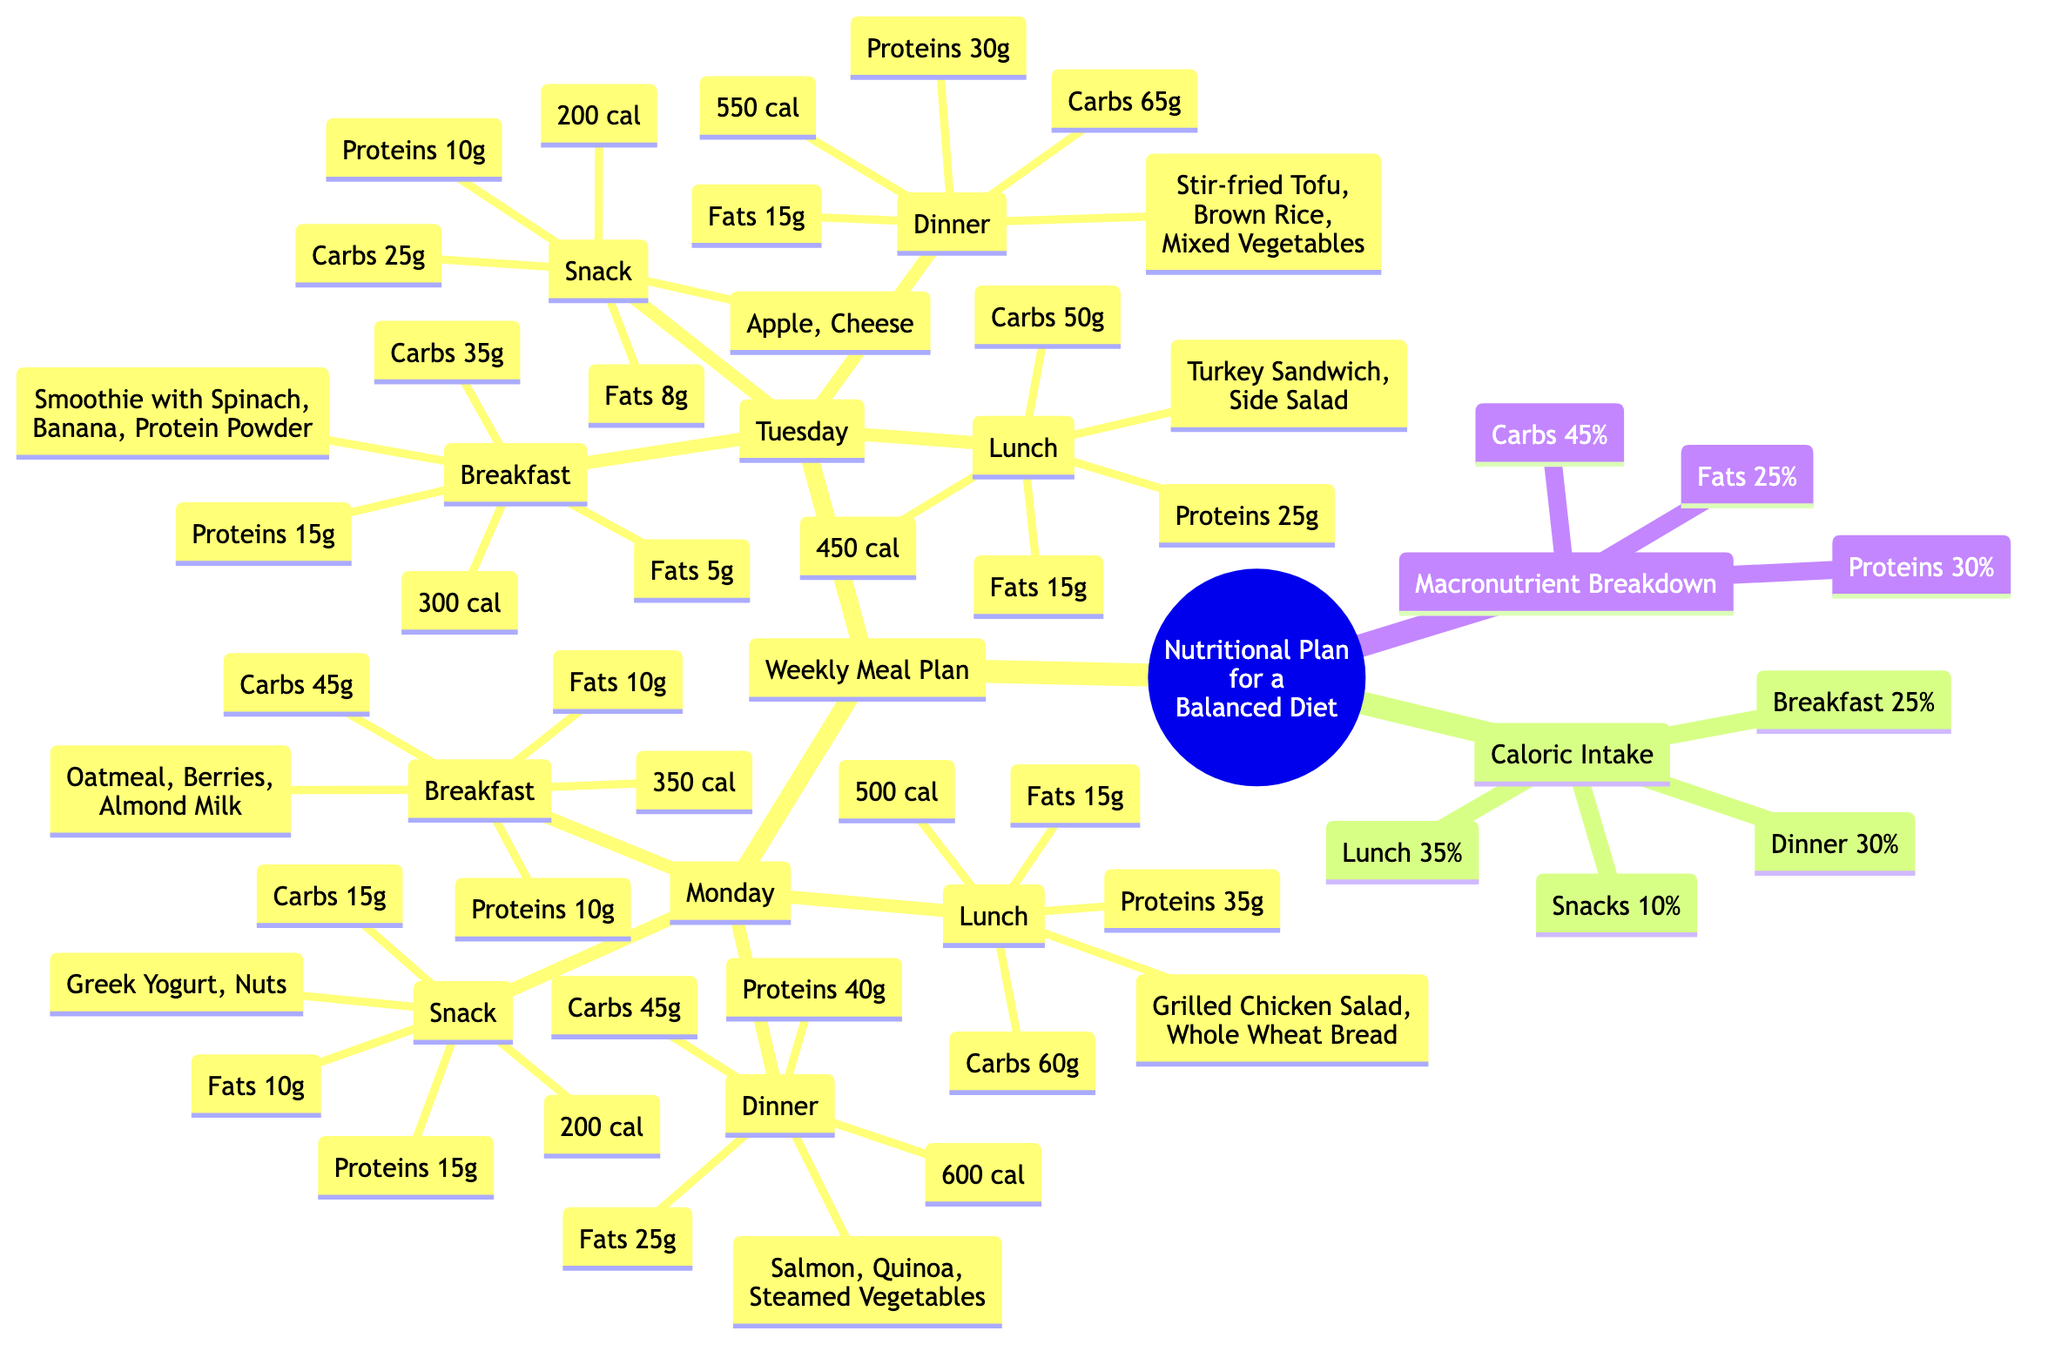What is the caloric intake for dinner on Monday? The diagram shows that the dinner on Monday consists of Salmon, Quinoa, and Steamed Vegetables, which amounts to a total of 600 calories listed next to the dinner node for Monday.
Answer: 600 cal What percentage of daily caloric intake is allocated for breakfast? The diagram specifies that breakfast makes up 25% of the total daily caloric intake in the section labeled "Caloric Intake."
Answer: 25% List one food included in Tuesday's lunch. The node for Tuesday's lunch mentions a Turkey Sandwich as one of the items included, so we refer directly to the lunch node for this information.
Answer: Turkey Sandwich How many grams of protein are in the snack on Monday? The snack on Monday is listed as Greek Yogurt and Nuts, with a breakdown showing that it contains 15 grams of protein alongside other nutritional information visible in the snack node.
Answer: 15g What is the total amount of carbohydrates for breakfast on Tuesday? Looking at Tuesday's breakfast node which includes a smoothie with Spinach, Banana, and Protein Powder, the total carbohydrate content is 35 grams as per the details provided in that node.
Answer: 35g What is the combined caloric intake for lunch on Monday and Tuesday? The caloric intake for lunch on Monday is 500 calories and for Tuesday is 450 calories. To find the combined total, we add these two values: 500 + 450 = 950 calories.
Answer: 950 cal What macronutrient constitutes the largest percentage in the weekly meal plan? The diagram indicates that carbohydrates make up 45% of the total macronutrient breakdown, which is the highest percentage compared to proteins at 30% and fats at 25%.
Answer: Carbs Which day has a lower caloric intake for dinner, Monday or Tuesday? The diagram specifies that Monday's dinner is 600 calories, while Tuesday's dinner, which includes Stir-fried Tofu, Brown Rice, and Mixed Vegetables, totals 550 calories. Since 550 calories is less than 600, Tuesday has the lower intake.
Answer: Tuesday What is the total number of meals listed in the weekly meal plan? The meal plan includes 4 meals (breakfast, lunch, dinner, and snack) for each of the 2 days presented, resulting in a total of 4 meals per day multiplied by 2 days gives us 8 meals total.
Answer: 8 